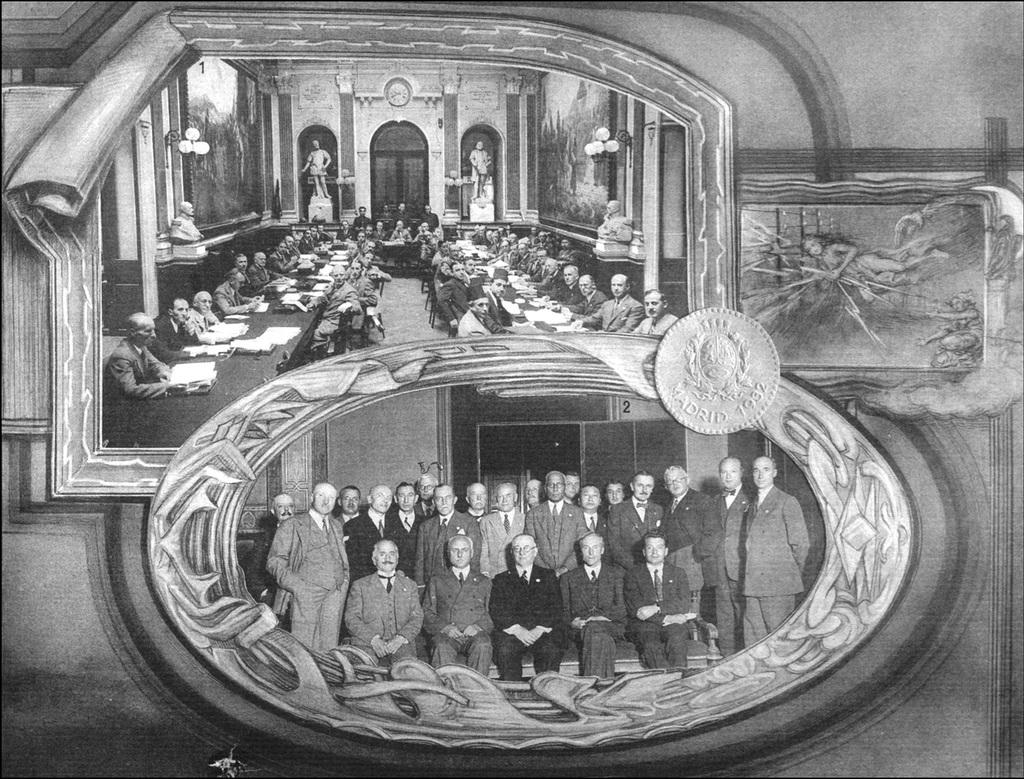What is the main subject of the image? The main subject of the image is a group of people. How are the people arranged in the image? The people are in frames in the image. What additional object can be seen in the image? There is a coin visible in the image. What type of advertisement can be seen in the image? There is no advertisement present in the image; it features a group of people in frames and a coin. 